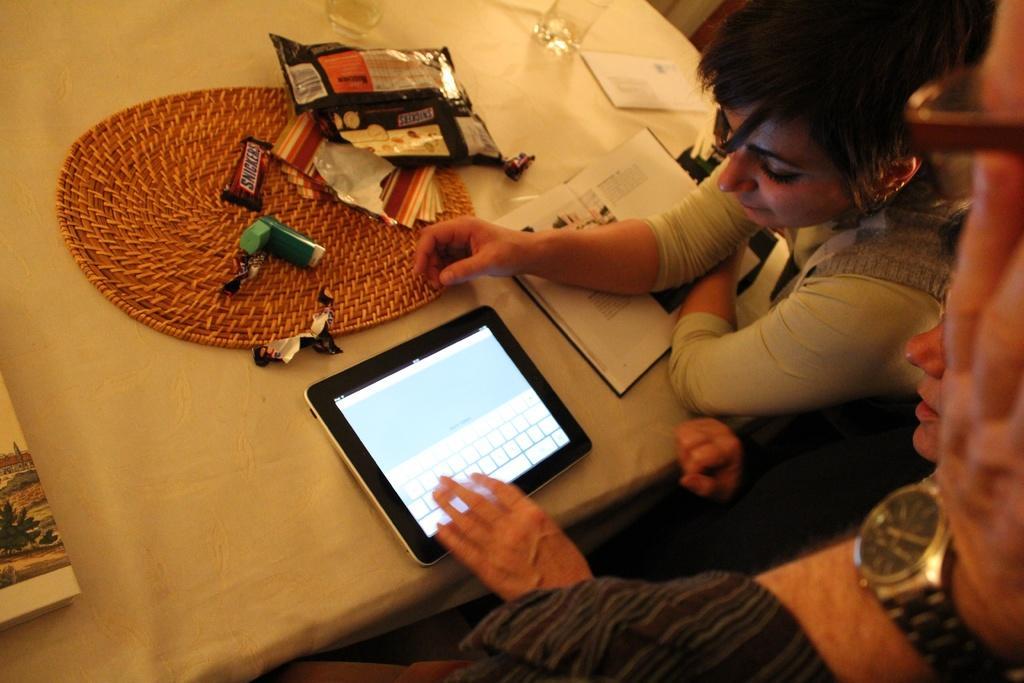Can you describe this image briefly? In the picture I can see a person´s hand wearing wrist watch and spectacles here and we can see two persons are sitting near the table where iPad, books, glasses, chocolates, packets and a few more things are placed on it. Here we can see a white color table cloth on the table. 